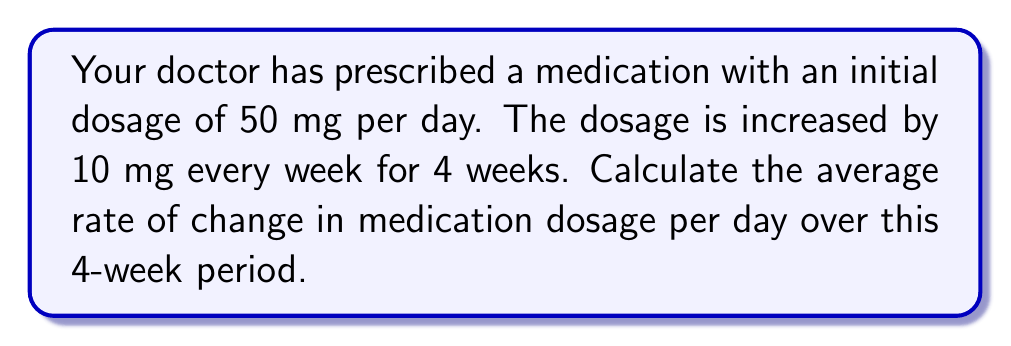What is the answer to this math problem? Let's approach this step-by-step:

1) First, let's identify the key information:
   - Initial dosage: 50 mg/day
   - Increase: 10 mg/week
   - Duration: 4 weeks

2) Calculate the final dosage after 4 weeks:
   $$ \text{Final dosage} = 50 + (10 \times 4) = 90 \text{ mg/day} $$

3) Calculate the total change in dosage:
   $$ \text{Total change} = 90 - 50 = 40 \text{ mg} $$

4) Convert the time period to days:
   $$ 4 \text{ weeks} = 4 \times 7 = 28 \text{ days} $$

5) Calculate the average rate of change:
   $$ \text{Average rate of change} = \frac{\text{Total change}}{\text{Time period}} $$
   $$ = \frac{40 \text{ mg}}{28 \text{ days}} $$
   $$ = \frac{10}{7} \approx 1.43 \text{ mg/day} $$

Thus, the average rate of change in medication dosage is approximately 1.43 mg per day over the 4-week period.
Answer: $\frac{10}{7} \approx 1.43 \text{ mg/day}$ 